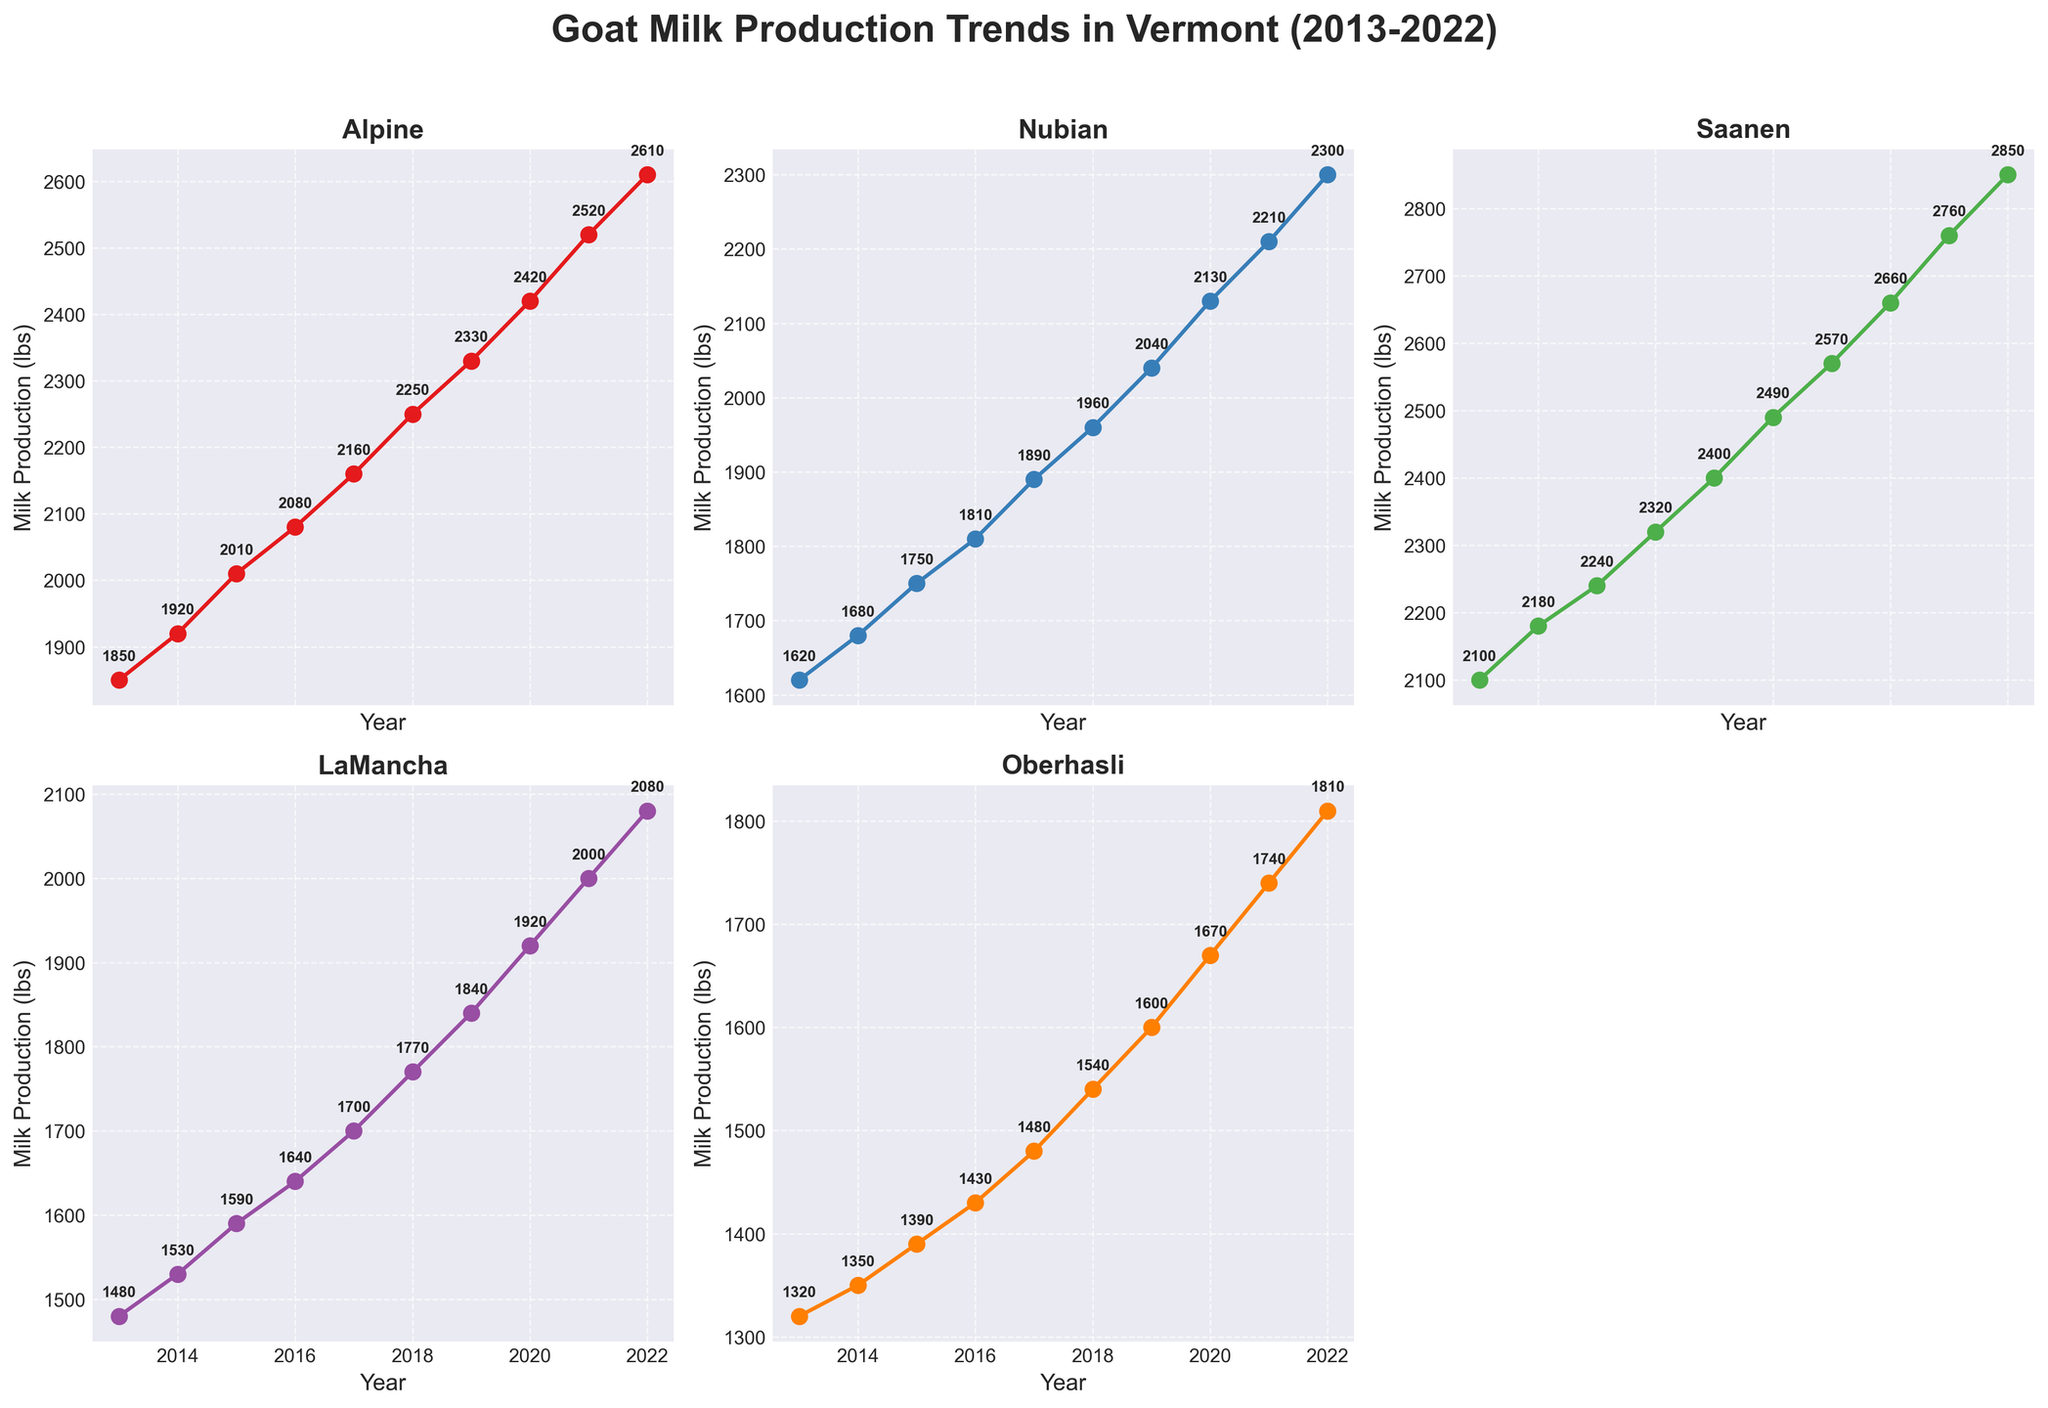What is the title of the figure? The title is located at the top of the figure. It states the overall topic of the plots.
Answer: Goat Milk Production Trends in Vermont (2013-2022) Which breed had the highest milk production in 2022? Locate the 2022 data point for all the breeds and find which one has the highest value. The topmost point in 2022 will indicate this.
Answer: Saanen How many breeds of goats are displayed in the chart? Each subplot represents a different breed. Count the unique subplots to determine the number of breeds shown.
Answer: 5 What is the trend in milk production for the Nubian breed from 2013 to 2022? Look at the line in the Nubian subplot. Note if the line is generally increasing, decreasing, or stable over time.
Answer: Increasing Which breed had the least milk production in 2017? Look at the 2017 data point for all the breeds and find which one has the lowest value. The bottommost point in 2017 will indicate this.
Answer: Oberhasli What is the average milk production for the Alpine breed over the decade? Sum all the milk production values for the Alpine breed from 2013 to 2022 and divide by the number of years (10). (1850+1920+2010+2080+2160+2250+2330+2420+2520+2610) / 10 = 2215
Answer: 2215 Did any breed of goat have a decrease in milk production during any year within the given period? Check the plot of each breed to see if there is at least one point where the production value is less than the previous year.
Answer: No Which breed shows the most consistent increase in milk production over the years? Look for the breed with the smoothest ascending line without annual declines.
Answer: Saanen Between Alpine and LaMancha, which breed had a faster increase in milk production from 2013 to 2022? Calculate the difference between the 2013 and 2022 values for both breeds and compare. Alpine: 2610 - 1850 = 760; LaMancha: 2080 - 1480 = 600. Alpine had a higher increase.
Answer: Alpine What was the difference in milk production between Saanen and Nubian in 2020? Subtract the Nubian value from the Saanen value in 2020. 2660 (Saanen) - 2130 (Nubian) = 530
Answer: 530 Which breed had its milk production cross 2000 lbs first and in which year? Check which breed first had a value of 2000 or more, ordered by year.
Answer: Saanen, 2012 